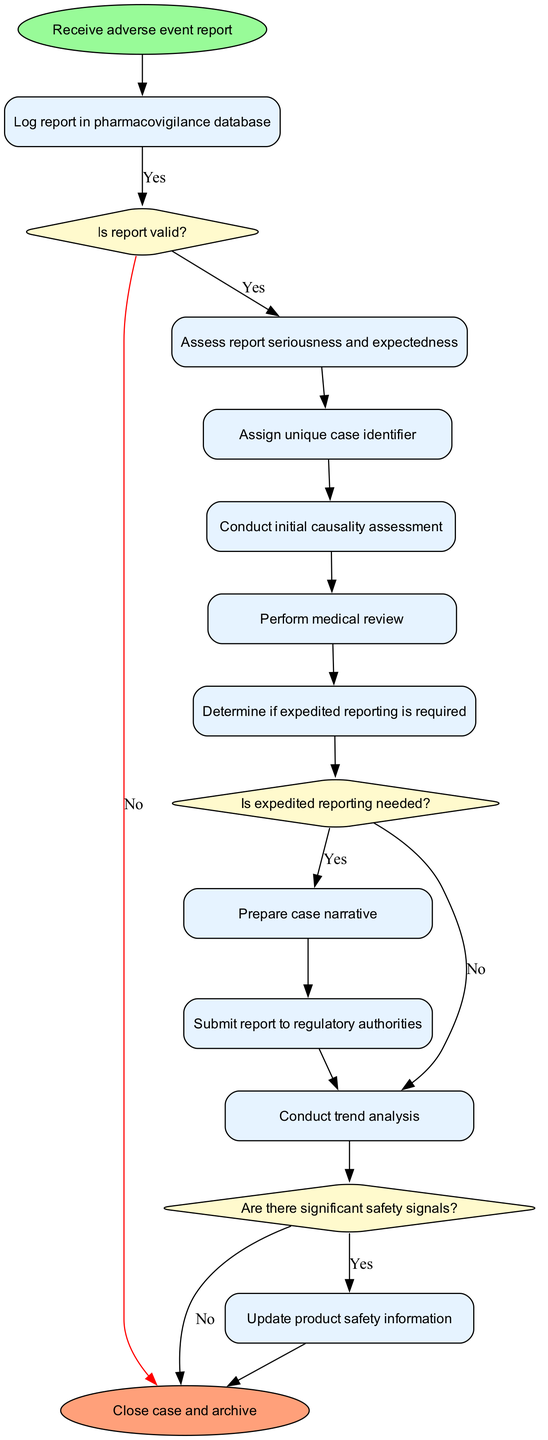What is the first activity in the diagram? The diagram starts with the "Receive adverse event report" node, which indicates the first activity in the pharmacovigilance process.
Answer: Receive adverse event report How many activities are present in the diagram? There are ten activities listed in the diagram, from logging the report to updating product safety information.
Answer: 10 What is the last activity before submission to regulatory authorities? The last activity before the "Submit report to regulatory authorities" node is the "Prepare case narrative," which directly precedes it in the sequence of activities.
Answer: Prepare case narrative What decision comes after assessing report seriousness and expectedness? After the "Assess report seriousness and expectedness," the next decision is "Is expedited reporting needed?" which evaluates whether expedited reporting needs to be done.
Answer: Is expedited reporting needed? What happens if the report is invalid? If the report is invalid, the flow leads directly to the "Close case and archive" node, skipping other activities and decisions.
Answer: Close case and archive How many decisions are there in the diagram? The diagram includes three decisions regarding the validity of the report, expedited reporting needs, and the presence of significant safety signals.
Answer: 3 If the expedited reporting is not needed, which activity follows next? If expedited reporting is not needed, the next activity in the flow is "Conduct trend analysis," as indicated by the flow from the decision "Is expedited reporting needed?" to the corresponding activity.
Answer: Conduct trend analysis What activity comes after "Determine if expedited reporting is required"? The activity that comes after "Determine if expedited reporting is required" is "Prepare case narrative," regardless of whether expedited reporting is needed or not.
Answer: Prepare case narrative How do trends in safety signals affect the process? If there are significant safety signals identified in the "Conduct trend analysis," the flow will lead to actions that update product safety information; otherwise, it will end the process.
Answer: Update product safety information 